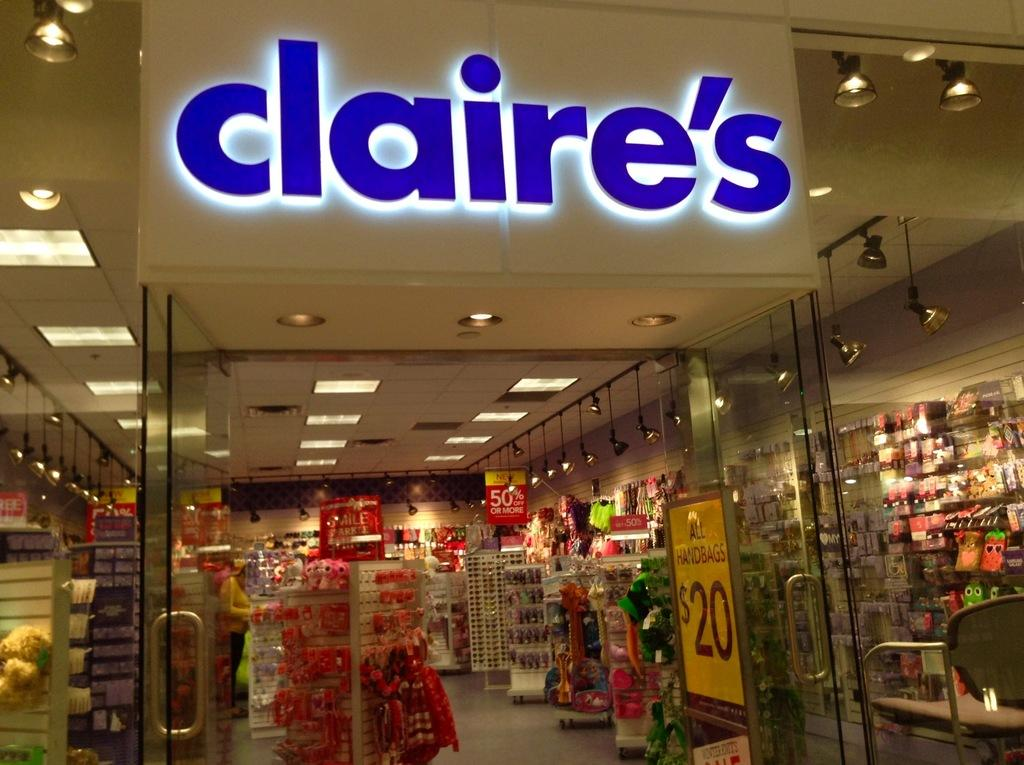<image>
Present a compact description of the photo's key features. The glass store front to a Claire's store where all handbags are $20. 